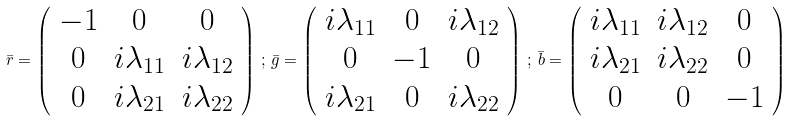Convert formula to latex. <formula><loc_0><loc_0><loc_500><loc_500>\bar { r } = \left ( \begin{array} { c c c } - 1 & 0 & 0 \\ 0 & i \lambda _ { 1 1 } & i \lambda _ { 1 2 } \\ 0 & i \lambda _ { 2 1 } & i \lambda _ { 2 2 } \end{array} \right ) \, ; \, \bar { g } = \left ( \begin{array} { c c c } i \lambda _ { 1 1 } & 0 & i \lambda _ { 1 2 } \\ 0 & - 1 & 0 \\ i \lambda _ { 2 1 } & 0 & i \lambda _ { 2 2 } \end{array} \right ) \, ; \, \bar { b } = \left ( \begin{array} { c c c } i \lambda _ { 1 1 } & i \lambda _ { 1 2 } & 0 \\ i \lambda _ { 2 1 } & i \lambda _ { 2 2 } & 0 \\ 0 & 0 & - 1 \end{array} \right )</formula> 